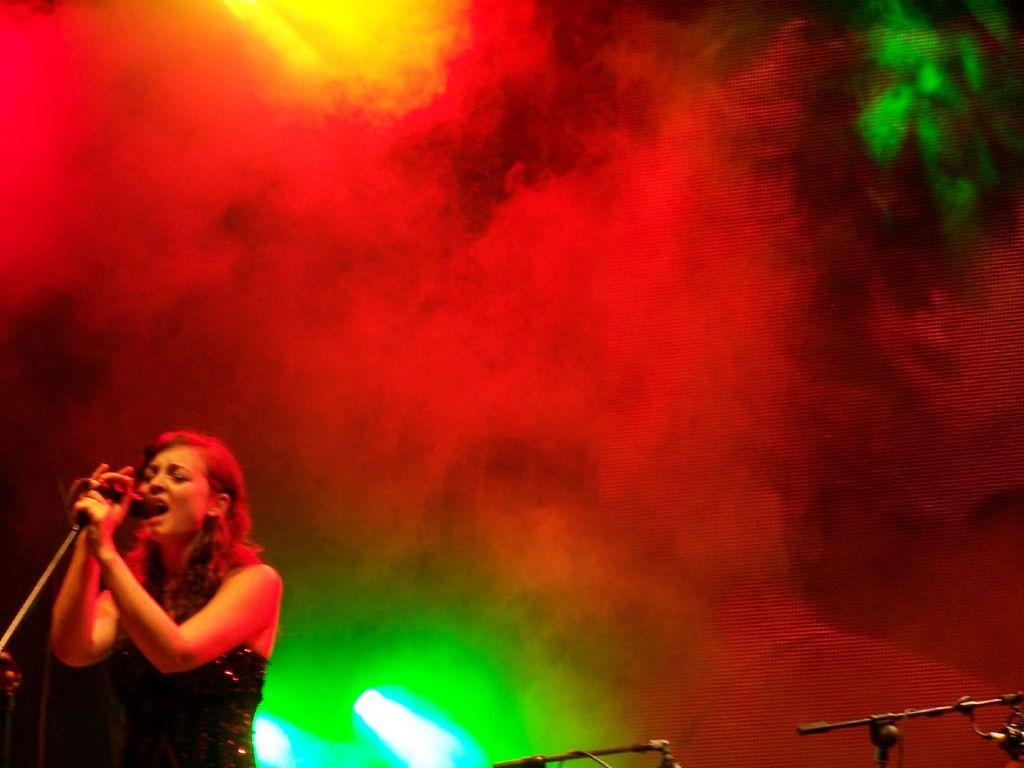Who is the main subject in the image? There is a woman in the image. What is the woman holding in the image? The woman is holding a microphone with a stand. What can be seen in the background of the image? There is smoke and lights visible in the image. What type of reward is the woman holding in the image? The woman is not holding a reward in the image; she is holding a microphone with a stand. Is there any baseball equipment visible in the image? There is no baseball equipment present in the image. 